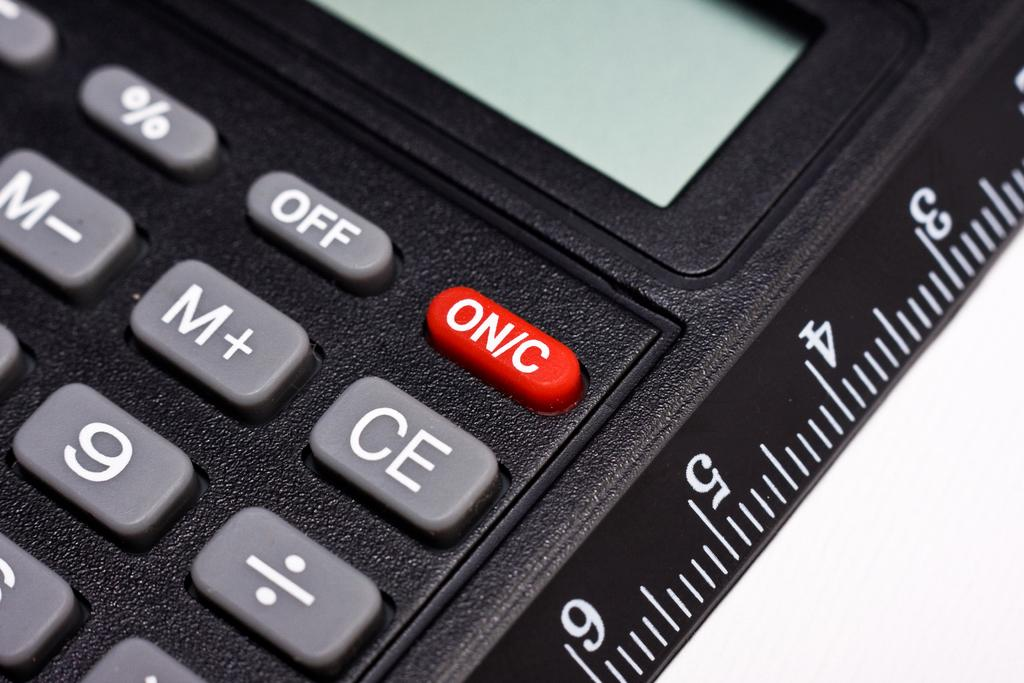<image>
Present a compact description of the photo's key features. A black calculator displaying several buttons including the ON/C button in red 